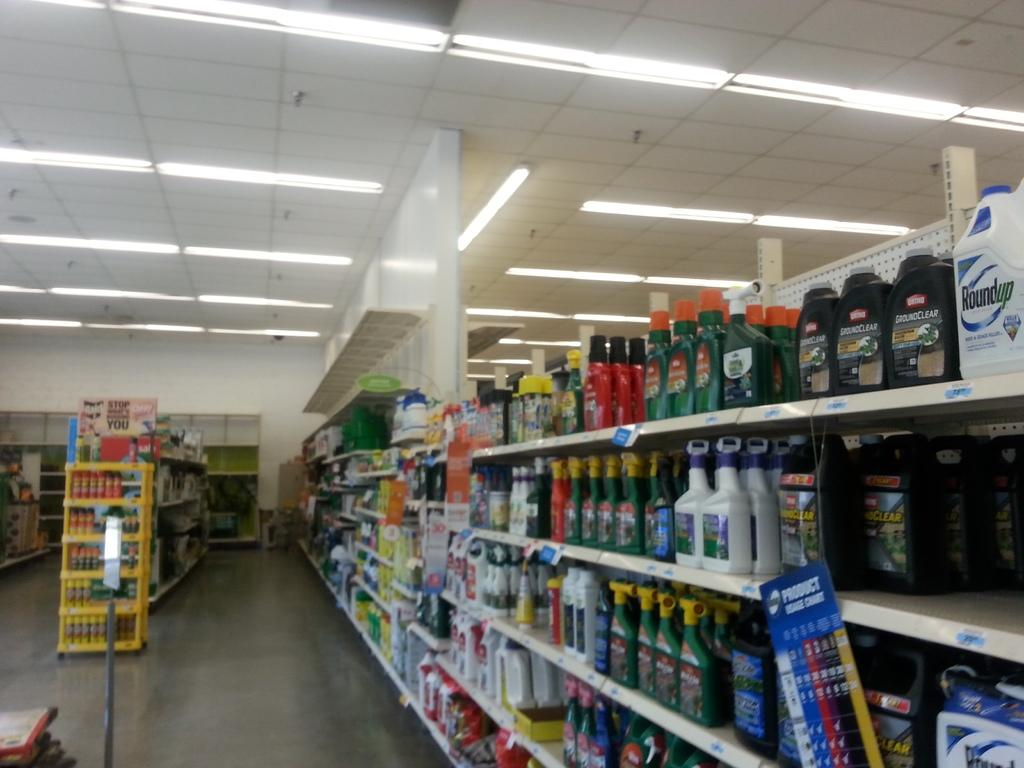Provide a one-sentence caption for the provided image. Store asile that has roundup on top shelf. 